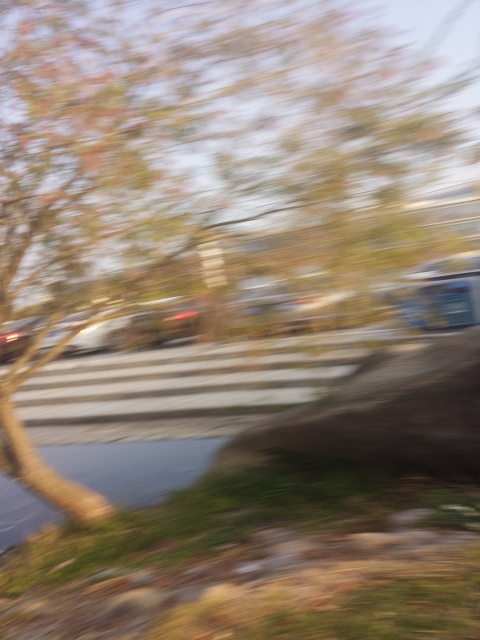What effect does the motion blur have on the image?
A. Blending effects
B. Sharpening effects
C. Distorting effects
D. Trailing effects
Answer with the option's letter from the given choices directly.
 D. 